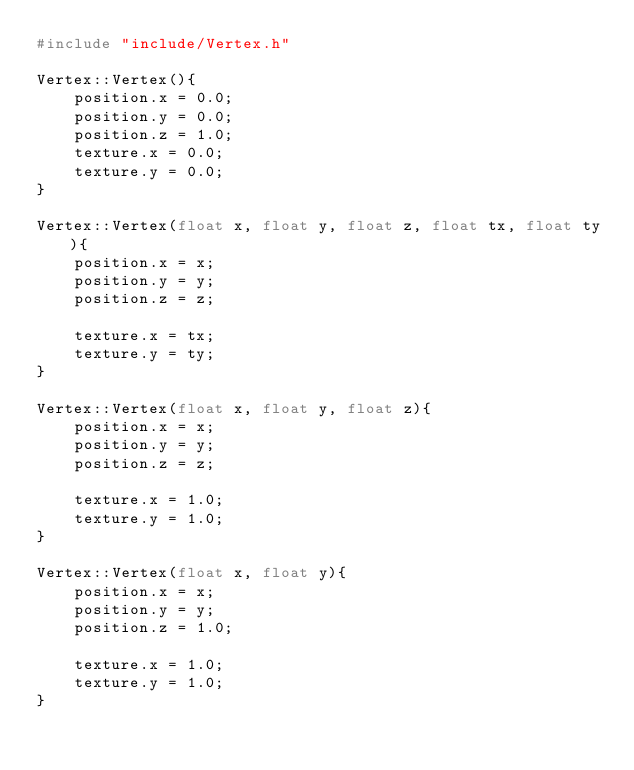<code> <loc_0><loc_0><loc_500><loc_500><_C++_>#include "include/Vertex.h"

Vertex::Vertex(){
	position.x = 0.0;
	position.y = 0.0;
	position.z = 1.0;
	texture.x = 0.0;
	texture.y = 0.0;
}

Vertex::Vertex(float x, float y, float z, float tx, float ty){
    position.x = x;
    position.y = y;
    position.z = z;

    texture.x = tx;
    texture.y = ty;
}

Vertex::Vertex(float x, float y, float z){
    position.x = x;
    position.y = y;
    position.z = z;

    texture.x = 1.0;
    texture.y = 1.0;
}

Vertex::Vertex(float x, float y){
    position.x = x;
    position.y = y;
    position.z = 1.0;

    texture.x = 1.0;
    texture.y = 1.0;
}

</code> 